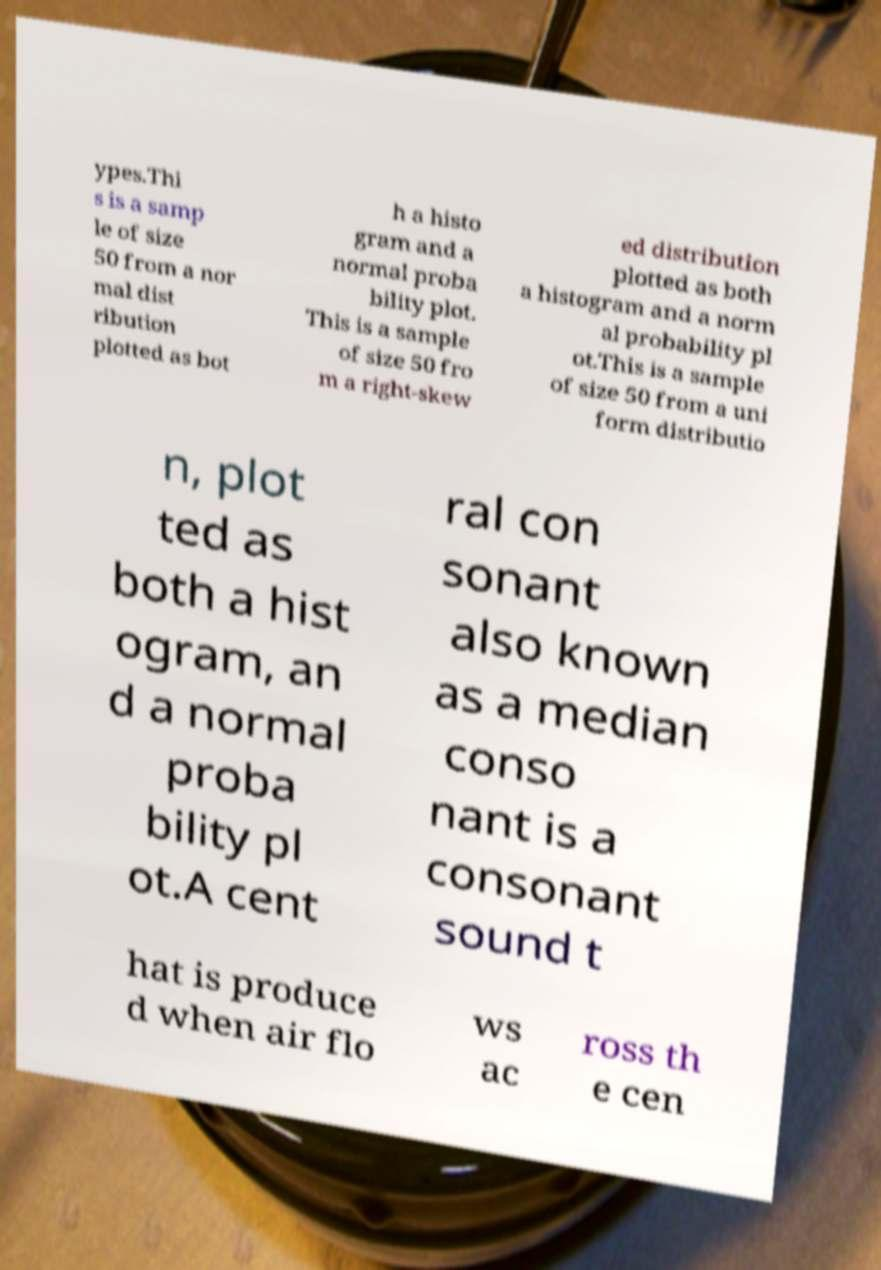Please identify and transcribe the text found in this image. ypes.Thi s is a samp le of size 50 from a nor mal dist ribution plotted as bot h a histo gram and a normal proba bility plot. This is a sample of size 50 fro m a right-skew ed distribution plotted as both a histogram and a norm al probability pl ot.This is a sample of size 50 from a uni form distributio n, plot ted as both a hist ogram, an d a normal proba bility pl ot.A cent ral con sonant also known as a median conso nant is a consonant sound t hat is produce d when air flo ws ac ross th e cen 